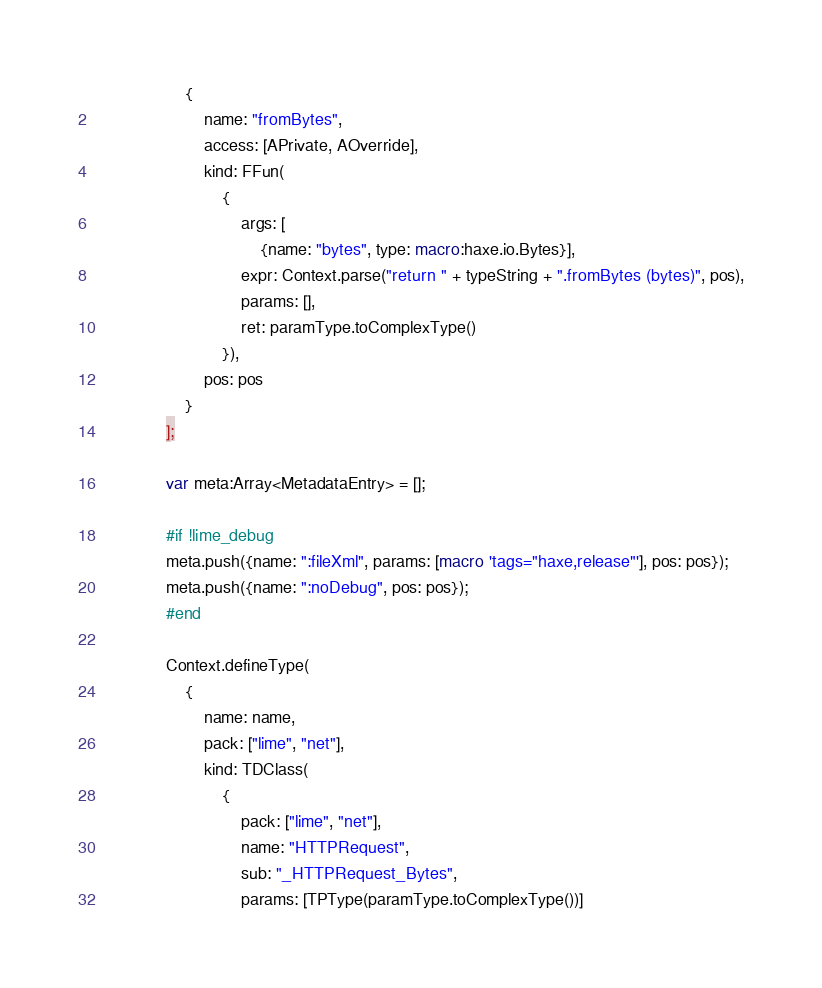Convert code to text. <code><loc_0><loc_0><loc_500><loc_500><_Haxe_>					{
						name: "fromBytes",
						access: [APrivate, AOverride],
						kind: FFun(
							{
								args: [
									{name: "bytes", type: macro:haxe.io.Bytes}],
								expr: Context.parse("return " + typeString + ".fromBytes (bytes)", pos),
								params: [],
								ret: paramType.toComplexType()
							}),
						pos: pos
					}
				];

				var meta:Array<MetadataEntry> = [];

				#if !lime_debug
				meta.push({name: ":fileXml", params: [macro 'tags="haxe,release"'], pos: pos});
				meta.push({name: ":noDebug", pos: pos});
				#end

				Context.defineType(
					{
						name: name,
						pack: ["lime", "net"],
						kind: TDClass(
							{
								pack: ["lime", "net"],
								name: "HTTPRequest",
								sub: "_HTTPRequest_Bytes",
								params: [TPType(paramType.toComplexType())]</code> 